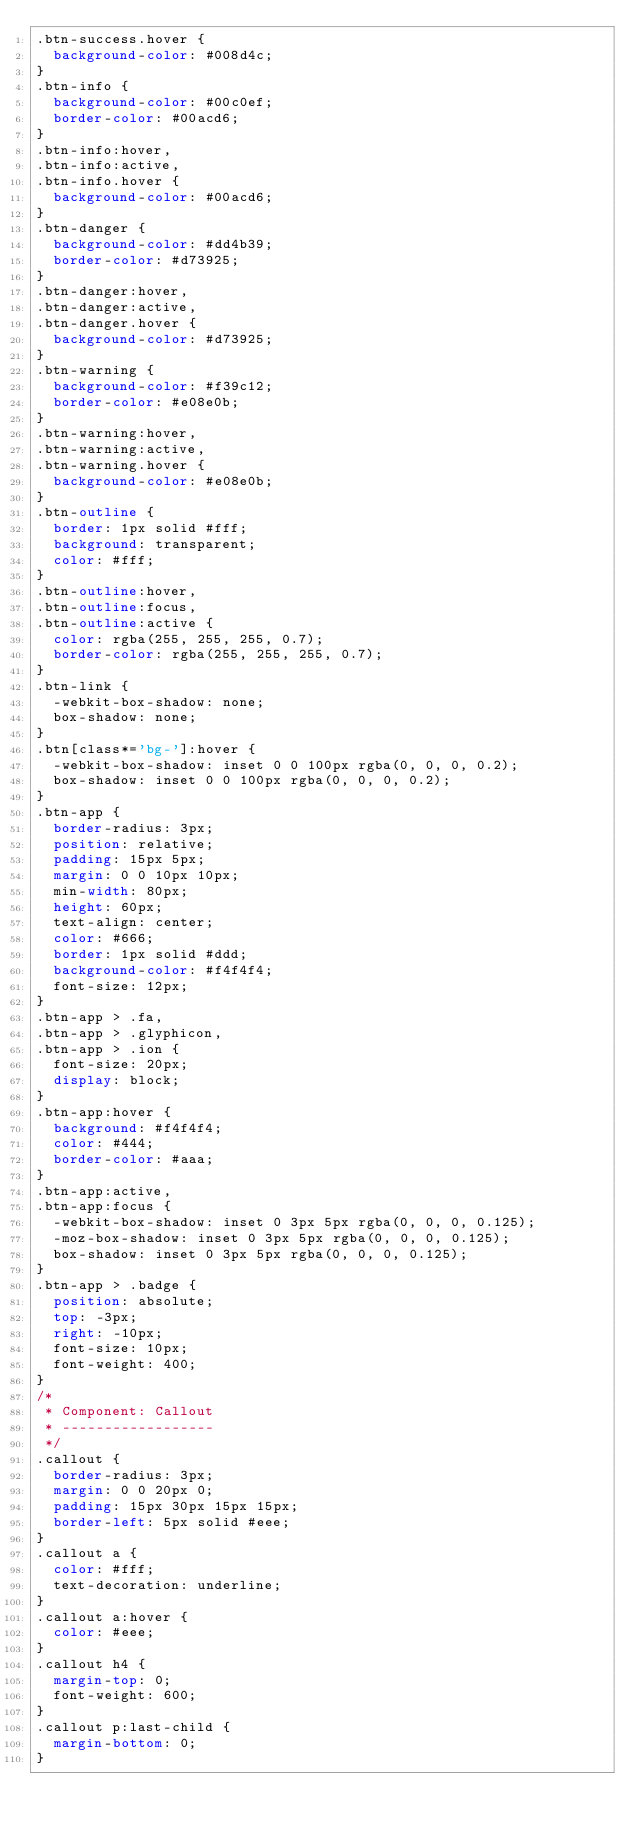Convert code to text. <code><loc_0><loc_0><loc_500><loc_500><_CSS_>.btn-success.hover {
  background-color: #008d4c;
}
.btn-info {
  background-color: #00c0ef;
  border-color: #00acd6;
}
.btn-info:hover,
.btn-info:active,
.btn-info.hover {
  background-color: #00acd6;
}
.btn-danger {
  background-color: #dd4b39;
  border-color: #d73925;
}
.btn-danger:hover,
.btn-danger:active,
.btn-danger.hover {
  background-color: #d73925;
}
.btn-warning {
  background-color: #f39c12;
  border-color: #e08e0b;
}
.btn-warning:hover,
.btn-warning:active,
.btn-warning.hover {
  background-color: #e08e0b;
}
.btn-outline {
  border: 1px solid #fff;
  background: transparent;
  color: #fff;
}
.btn-outline:hover,
.btn-outline:focus,
.btn-outline:active {
  color: rgba(255, 255, 255, 0.7);
  border-color: rgba(255, 255, 255, 0.7);
}
.btn-link {
  -webkit-box-shadow: none;
  box-shadow: none;
}
.btn[class*='bg-']:hover {
  -webkit-box-shadow: inset 0 0 100px rgba(0, 0, 0, 0.2);
  box-shadow: inset 0 0 100px rgba(0, 0, 0, 0.2);
}
.btn-app {
  border-radius: 3px;
  position: relative;
  padding: 15px 5px;
  margin: 0 0 10px 10px;
  min-width: 80px;
  height: 60px;
  text-align: center;
  color: #666;
  border: 1px solid #ddd;
  background-color: #f4f4f4;
  font-size: 12px;
}
.btn-app > .fa,
.btn-app > .glyphicon,
.btn-app > .ion {
  font-size: 20px;
  display: block;
}
.btn-app:hover {
  background: #f4f4f4;
  color: #444;
  border-color: #aaa;
}
.btn-app:active,
.btn-app:focus {
  -webkit-box-shadow: inset 0 3px 5px rgba(0, 0, 0, 0.125);
  -moz-box-shadow: inset 0 3px 5px rgba(0, 0, 0, 0.125);
  box-shadow: inset 0 3px 5px rgba(0, 0, 0, 0.125);
}
.btn-app > .badge {
  position: absolute;
  top: -3px;
  right: -10px;
  font-size: 10px;
  font-weight: 400;
}
/*
 * Component: Callout
 * ------------------
 */
.callout {
  border-radius: 3px;
  margin: 0 0 20px 0;
  padding: 15px 30px 15px 15px;
  border-left: 5px solid #eee;
}
.callout a {
  color: #fff;
  text-decoration: underline;
}
.callout a:hover {
  color: #eee;
}
.callout h4 {
  margin-top: 0;
  font-weight: 600;
}
.callout p:last-child {
  margin-bottom: 0;
}</code> 